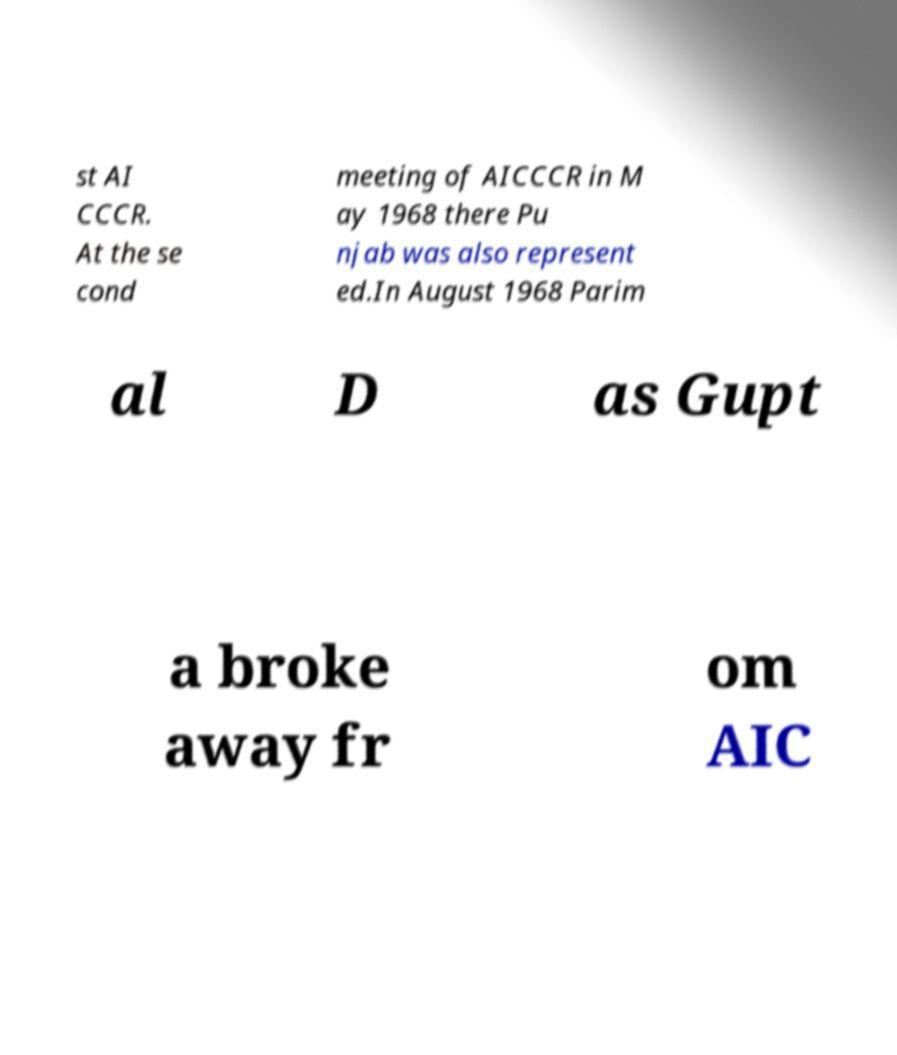Please identify and transcribe the text found in this image. st AI CCCR. At the se cond meeting of AICCCR in M ay 1968 there Pu njab was also represent ed.In August 1968 Parim al D as Gupt a broke away fr om AIC 